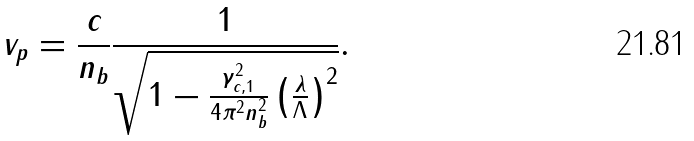<formula> <loc_0><loc_0><loc_500><loc_500>v _ { p } = \frac { c } { n _ { b } } \frac { 1 } { \sqrt { 1 - \frac { \gamma _ { c , 1 } ^ { 2 } } { 4 \pi ^ { 2 } n _ { b } ^ { 2 } } \left ( \frac { \lambda } { \Lambda } \right ) ^ { 2 } } } .</formula> 